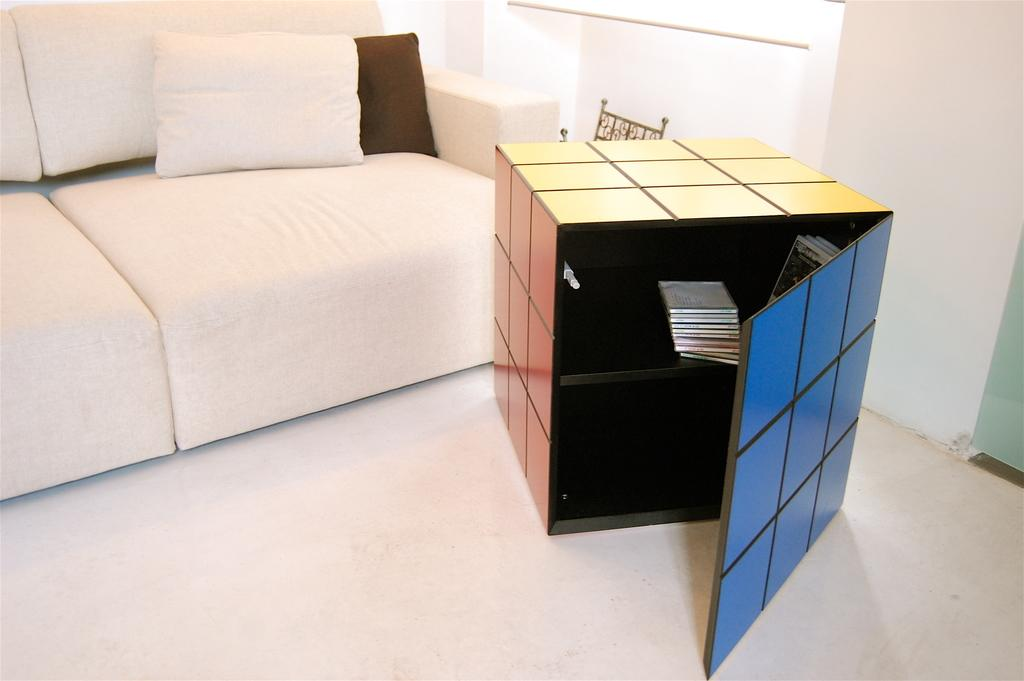What type of furniture is present in the image? There is a sofa in the image. What is placed on the sofa? There are two pillows on the sofa. What other type of furniture can be seen in the image? There is a cupboard in the image. What type of pie is being served on the sofa in the image? There is no pie present in the image; it features a sofa with two pillows and a cupboard. 